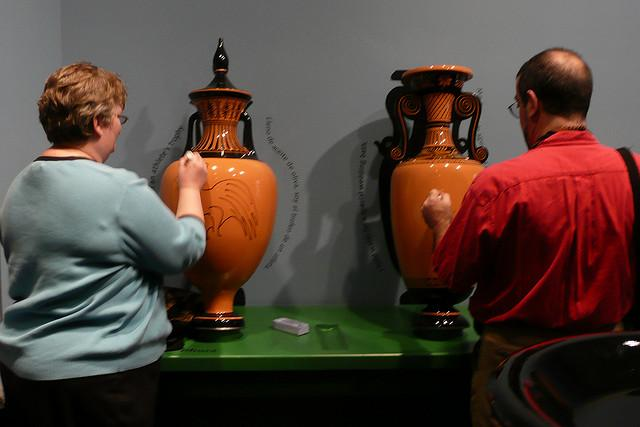What is the woman drawing? Please explain your reasoning. rooster. The woman is drawing a cock. 